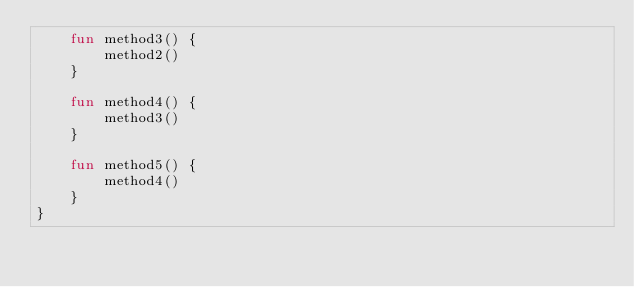<code> <loc_0><loc_0><loc_500><loc_500><_Kotlin_>    fun method3() {
        method2()
    }

    fun method4() {
        method3()
    }

    fun method5() {
        method4()
    }
}
</code> 